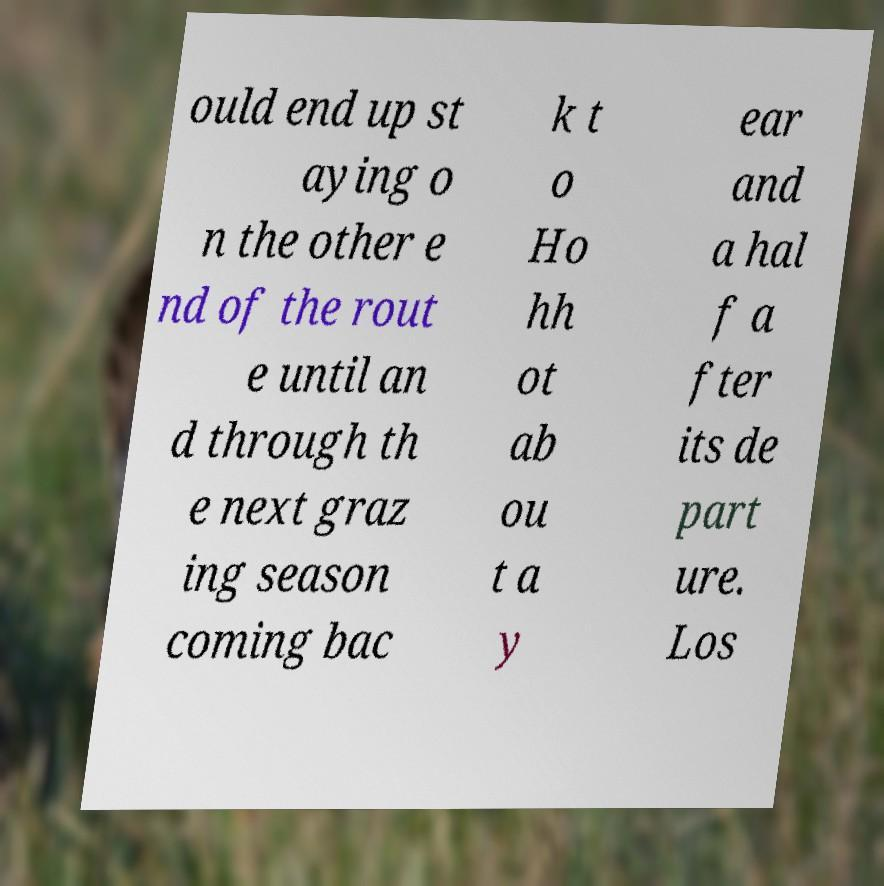I need the written content from this picture converted into text. Can you do that? ould end up st aying o n the other e nd of the rout e until an d through th e next graz ing season coming bac k t o Ho hh ot ab ou t a y ear and a hal f a fter its de part ure. Los 